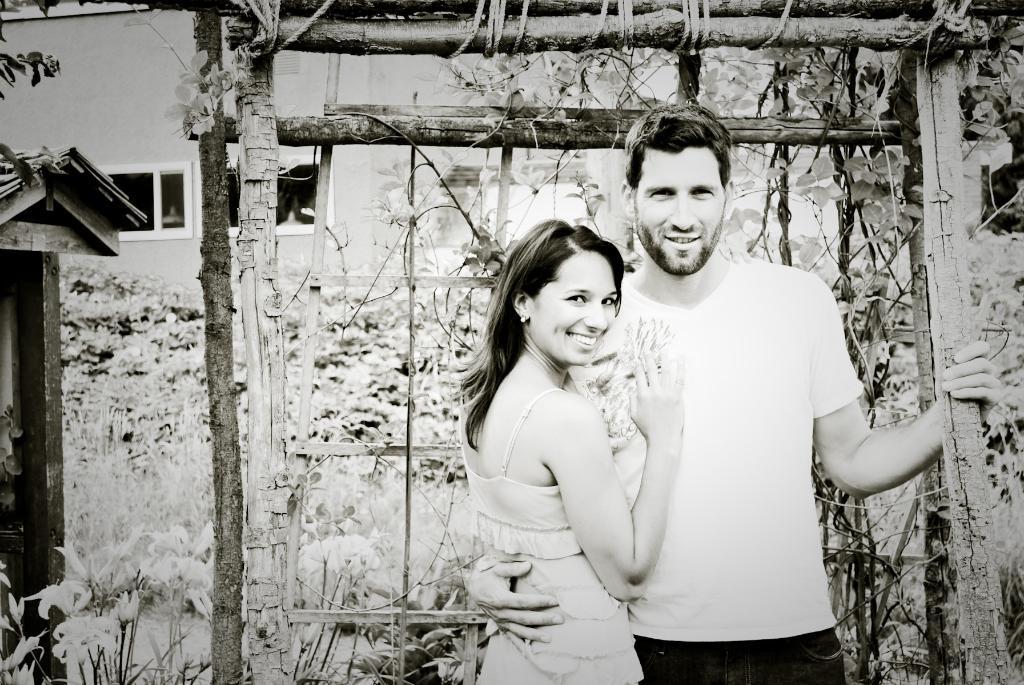In one or two sentences, can you explain what this image depicts? In this image, we can see a man and a lady smiling and in the background, there is a wood, trees and buildings. 